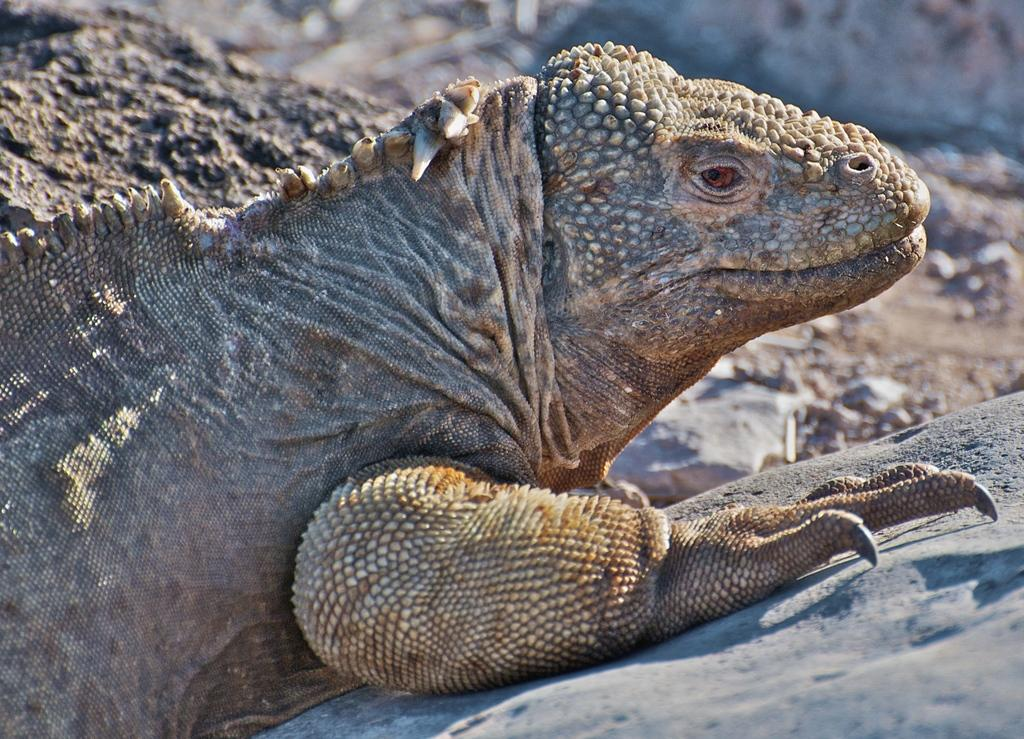What type of animal can be seen in the picture? There is a reptile in the picture. What is the terrain like in the picture? There are rocks on the ground in the picture. What type of mine is visible in the picture? There is no mine present in the picture; it features a reptile and rocks on the ground. 